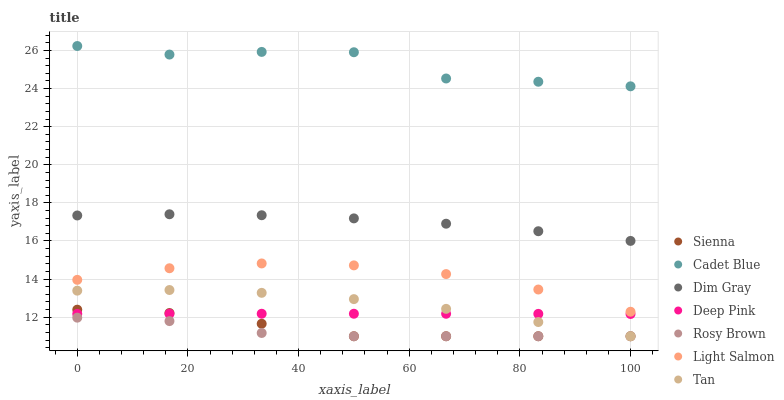Does Rosy Brown have the minimum area under the curve?
Answer yes or no. Yes. Does Cadet Blue have the maximum area under the curve?
Answer yes or no. Yes. Does Dim Gray have the minimum area under the curve?
Answer yes or no. No. Does Dim Gray have the maximum area under the curve?
Answer yes or no. No. Is Deep Pink the smoothest?
Answer yes or no. Yes. Is Cadet Blue the roughest?
Answer yes or no. Yes. Is Dim Gray the smoothest?
Answer yes or no. No. Is Dim Gray the roughest?
Answer yes or no. No. Does Rosy Brown have the lowest value?
Answer yes or no. Yes. Does Dim Gray have the lowest value?
Answer yes or no. No. Does Cadet Blue have the highest value?
Answer yes or no. Yes. Does Dim Gray have the highest value?
Answer yes or no. No. Is Sienna less than Light Salmon?
Answer yes or no. Yes. Is Dim Gray greater than Light Salmon?
Answer yes or no. Yes. Does Tan intersect Rosy Brown?
Answer yes or no. Yes. Is Tan less than Rosy Brown?
Answer yes or no. No. Is Tan greater than Rosy Brown?
Answer yes or no. No. Does Sienna intersect Light Salmon?
Answer yes or no. No. 